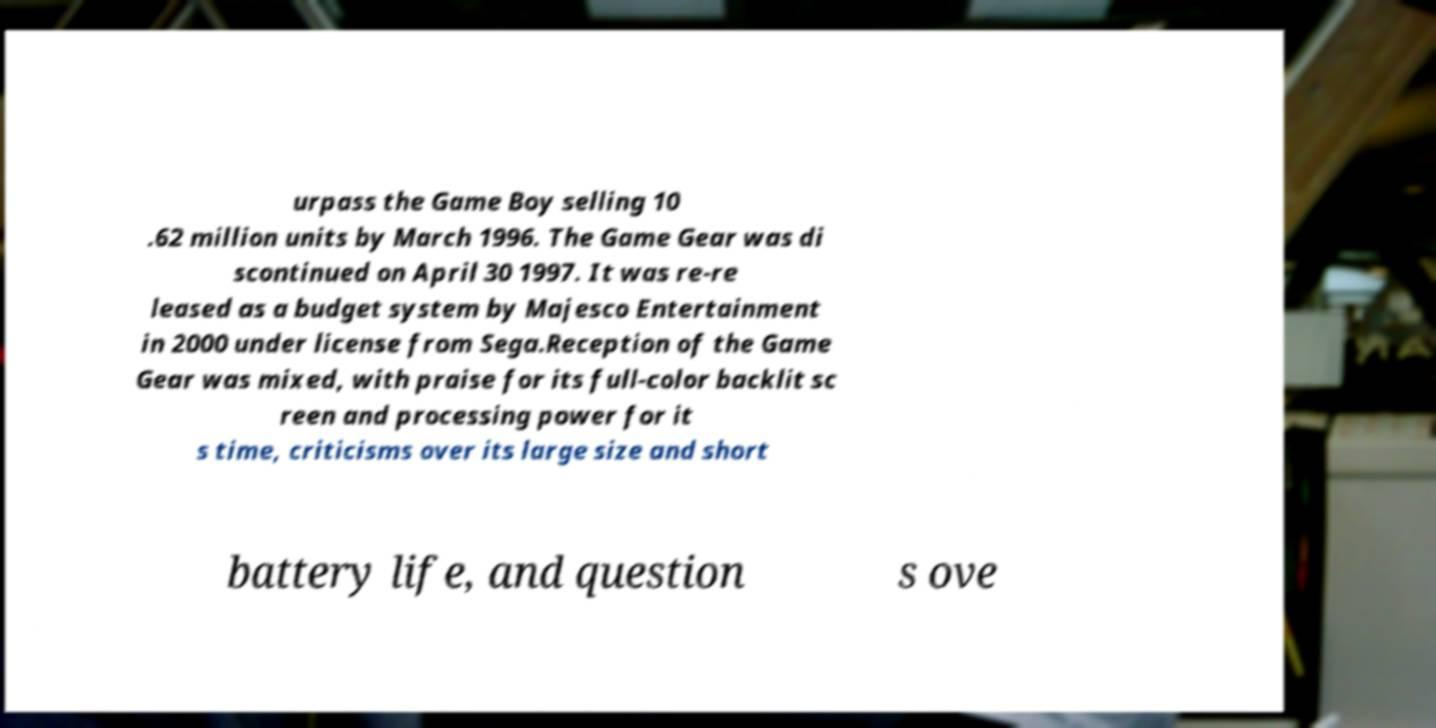Could you assist in decoding the text presented in this image and type it out clearly? urpass the Game Boy selling 10 .62 million units by March 1996. The Game Gear was di scontinued on April 30 1997. It was re-re leased as a budget system by Majesco Entertainment in 2000 under license from Sega.Reception of the Game Gear was mixed, with praise for its full-color backlit sc reen and processing power for it s time, criticisms over its large size and short battery life, and question s ove 